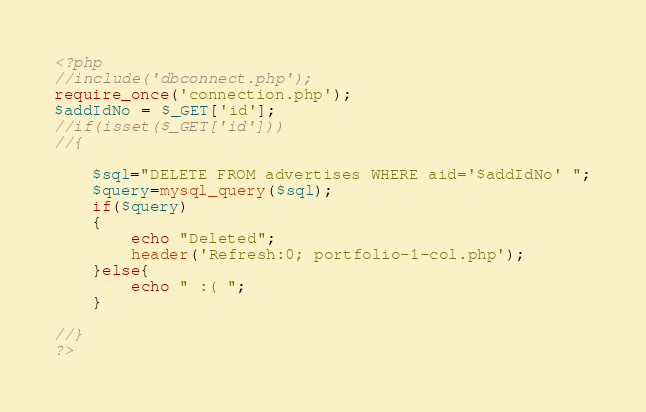Convert code to text. <code><loc_0><loc_0><loc_500><loc_500><_PHP_><?php
//include('dbconnect.php'); 
require_once('connection.php');
$addIdNo = $_GET['id'];
//if(isset($_GET['id']))
//{

	$sql="DELETE FROM advertises WHERE aid='$addIdNo' ";
	$query=mysql_query($sql);
	if($query)
	{
		echo "Deleted";
		header('Refresh:0; portfolio-1-col.php');
	}else{
		echo " :( ";
	}

//}
?></code> 